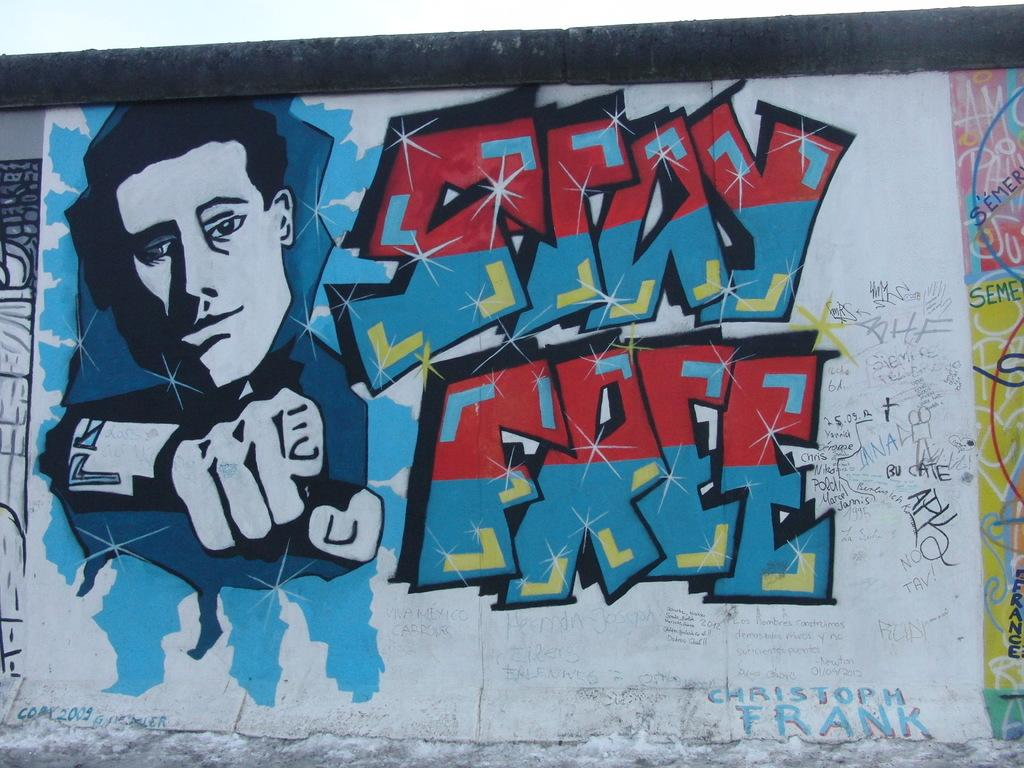Provide a one-sentence caption for the provided image. Graffiti on a wall tells people to stay free. 